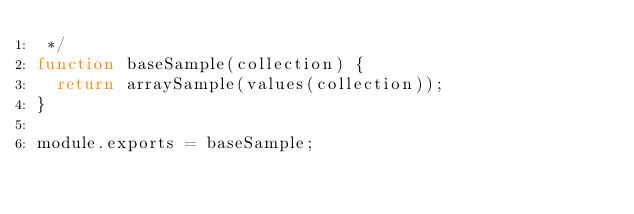<code> <loc_0><loc_0><loc_500><loc_500><_JavaScript_> */
function baseSample(collection) {
  return arraySample(values(collection));
}

module.exports = baseSample;</code> 